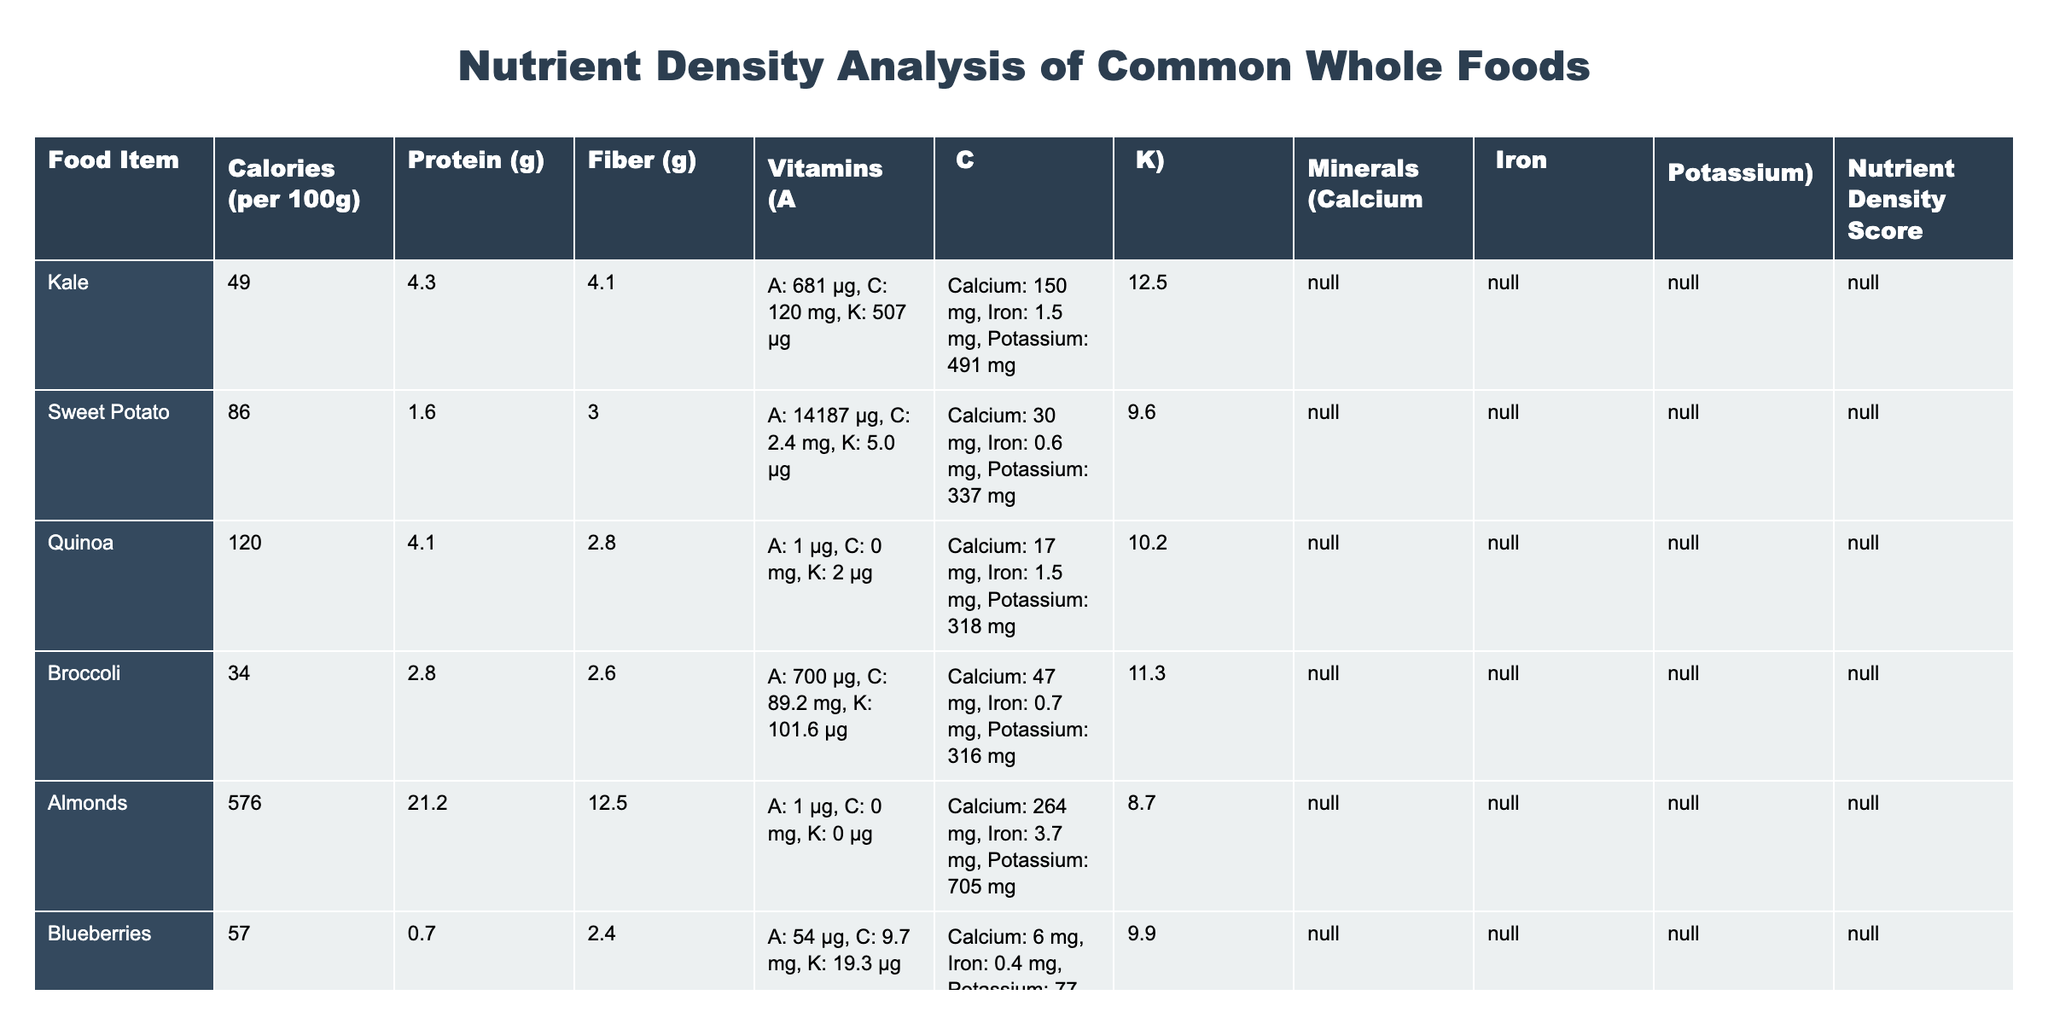What is the nutrient density score of kale? The table shows that the nutrient density score of kale is listed as 12.5.
Answer: 12.5 Which food item has the highest protein content per 100g? By examining the protein values in the table, almonds have the highest protein content at 21.2g.
Answer: 21.2g What is the fiber content of spinach? The table indicates that spinach contains 2.2g of fiber per 100g.
Answer: 2.2g Which food has the lowest calories per 100g? From the table, spinach is the food item with the lowest calories, at only 23 calories per 100g.
Answer: 23 calories Is the vitamin C content of blueberries greater than that of sweet potatoes? The table lists vitamin C content for blueberries as 9.7 mg and for sweet potatoes as 2.4 mg. Since 9.7 mg is greater than 2.4 mg, the statement is true.
Answer: Yes What is the average nutrient density score of lentils and chickpeas? The nutrient density scores are 10.5 for lentils and 9.4 for chickpeas. Summing them gives 19.9, then dividing by 2 gives an average of 9.95.
Answer: 9.95 How much more calcium does almonds contain compared to broccoli? The calcium content for almonds is 264 mg and for broccoli is 47 mg. The difference is 264 - 47 = 217 mg.
Answer: 217 mg Which food item has the highest vitamin A content, and how much is it? Looking at the vitamin A content in the table, sweet potato has the highest at 14187 µg.
Answer: Sweet potato, 14187 µg If you combine the potassium content of kale and spinach, what is the total? The potassium content for kale is 491 mg and for spinach is 558 mg. Adding them together, 491 + 558 = 1049 mg.
Answer: 1049 mg Are there any foods in the table that provide more than 10g of protein per 100g? The table shows that both lentils and almonds exceed 10g of protein per 100g. Therefore, the answer is yes.
Answer: Yes 